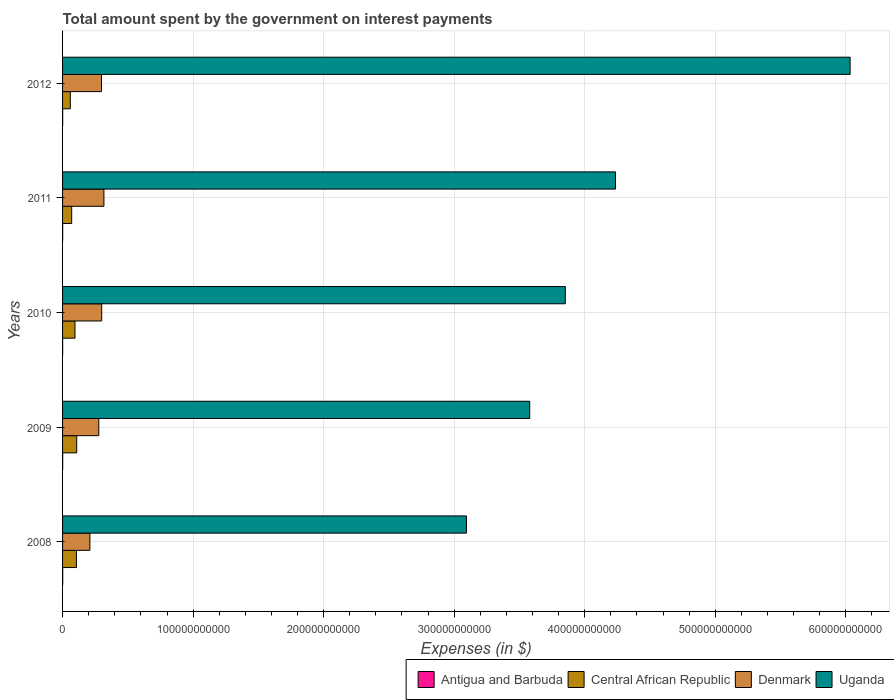How many groups of bars are there?
Your response must be concise. 5. Are the number of bars per tick equal to the number of legend labels?
Provide a short and direct response. Yes. Are the number of bars on each tick of the Y-axis equal?
Offer a very short reply. Yes. How many bars are there on the 1st tick from the top?
Ensure brevity in your answer.  4. How many bars are there on the 2nd tick from the bottom?
Your answer should be very brief. 4. In how many cases, is the number of bars for a given year not equal to the number of legend labels?
Keep it short and to the point. 0. What is the amount spent on interest payments by the government in Uganda in 2011?
Offer a terse response. 4.24e+11. Across all years, what is the maximum amount spent on interest payments by the government in Uganda?
Your response must be concise. 6.03e+11. Across all years, what is the minimum amount spent on interest payments by the government in Antigua and Barbuda?
Your answer should be very brief. 7.26e+07. In which year was the amount spent on interest payments by the government in Uganda maximum?
Offer a terse response. 2012. In which year was the amount spent on interest payments by the government in Central African Republic minimum?
Your answer should be compact. 2012. What is the total amount spent on interest payments by the government in Central African Republic in the graph?
Your response must be concise. 4.39e+1. What is the difference between the amount spent on interest payments by the government in Central African Republic in 2009 and that in 2011?
Provide a succinct answer. 3.85e+09. What is the difference between the amount spent on interest payments by the government in Denmark in 2010 and the amount spent on interest payments by the government in Antigua and Barbuda in 2008?
Provide a succinct answer. 2.99e+1. What is the average amount spent on interest payments by the government in Uganda per year?
Your answer should be very brief. 4.16e+11. In the year 2011, what is the difference between the amount spent on interest payments by the government in Central African Republic and amount spent on interest payments by the government in Uganda?
Provide a short and direct response. -4.17e+11. In how many years, is the amount spent on interest payments by the government in Uganda greater than 360000000000 $?
Provide a short and direct response. 3. What is the ratio of the amount spent on interest payments by the government in Denmark in 2010 to that in 2011?
Provide a succinct answer. 0.95. What is the difference between the highest and the second highest amount spent on interest payments by the government in Uganda?
Give a very brief answer. 1.80e+11. What is the difference between the highest and the lowest amount spent on interest payments by the government in Denmark?
Ensure brevity in your answer.  1.08e+1. In how many years, is the amount spent on interest payments by the government in Denmark greater than the average amount spent on interest payments by the government in Denmark taken over all years?
Give a very brief answer. 3. What does the 3rd bar from the top in 2009 represents?
Ensure brevity in your answer.  Central African Republic. What does the 2nd bar from the bottom in 2011 represents?
Offer a very short reply. Central African Republic. Is it the case that in every year, the sum of the amount spent on interest payments by the government in Central African Republic and amount spent on interest payments by the government in Denmark is greater than the amount spent on interest payments by the government in Antigua and Barbuda?
Make the answer very short. Yes. Are all the bars in the graph horizontal?
Your answer should be very brief. Yes. How many years are there in the graph?
Provide a succinct answer. 5. What is the difference between two consecutive major ticks on the X-axis?
Your answer should be very brief. 1.00e+11. Are the values on the major ticks of X-axis written in scientific E-notation?
Offer a terse response. No. Where does the legend appear in the graph?
Offer a terse response. Bottom right. What is the title of the graph?
Offer a very short reply. Total amount spent by the government on interest payments. Does "El Salvador" appear as one of the legend labels in the graph?
Provide a short and direct response. No. What is the label or title of the X-axis?
Provide a succinct answer. Expenses (in $). What is the label or title of the Y-axis?
Your answer should be compact. Years. What is the Expenses (in $) of Antigua and Barbuda in 2008?
Offer a very short reply. 1.03e+08. What is the Expenses (in $) in Central African Republic in 2008?
Provide a succinct answer. 1.06e+1. What is the Expenses (in $) of Denmark in 2008?
Offer a very short reply. 2.09e+1. What is the Expenses (in $) of Uganda in 2008?
Provide a short and direct response. 3.09e+11. What is the Expenses (in $) in Antigua and Barbuda in 2009?
Provide a succinct answer. 9.56e+07. What is the Expenses (in $) in Central African Republic in 2009?
Provide a short and direct response. 1.08e+1. What is the Expenses (in $) in Denmark in 2009?
Offer a terse response. 2.78e+1. What is the Expenses (in $) of Uganda in 2009?
Give a very brief answer. 3.58e+11. What is the Expenses (in $) in Antigua and Barbuda in 2010?
Provide a short and direct response. 7.26e+07. What is the Expenses (in $) of Central African Republic in 2010?
Your answer should be very brief. 9.51e+09. What is the Expenses (in $) of Denmark in 2010?
Offer a terse response. 3.00e+1. What is the Expenses (in $) in Uganda in 2010?
Offer a very short reply. 3.85e+11. What is the Expenses (in $) in Antigua and Barbuda in 2011?
Your answer should be compact. 7.73e+07. What is the Expenses (in $) in Central African Republic in 2011?
Provide a short and direct response. 6.98e+09. What is the Expenses (in $) of Denmark in 2011?
Ensure brevity in your answer.  3.17e+1. What is the Expenses (in $) in Uganda in 2011?
Offer a very short reply. 4.24e+11. What is the Expenses (in $) in Antigua and Barbuda in 2012?
Your answer should be very brief. 8.00e+07. What is the Expenses (in $) in Central African Republic in 2012?
Offer a terse response. 5.92e+09. What is the Expenses (in $) in Denmark in 2012?
Provide a short and direct response. 2.98e+1. What is the Expenses (in $) of Uganda in 2012?
Offer a very short reply. 6.03e+11. Across all years, what is the maximum Expenses (in $) of Antigua and Barbuda?
Ensure brevity in your answer.  1.03e+08. Across all years, what is the maximum Expenses (in $) in Central African Republic?
Your response must be concise. 1.08e+1. Across all years, what is the maximum Expenses (in $) of Denmark?
Your answer should be very brief. 3.17e+1. Across all years, what is the maximum Expenses (in $) of Uganda?
Ensure brevity in your answer.  6.03e+11. Across all years, what is the minimum Expenses (in $) in Antigua and Barbuda?
Offer a very short reply. 7.26e+07. Across all years, what is the minimum Expenses (in $) of Central African Republic?
Your answer should be very brief. 5.92e+09. Across all years, what is the minimum Expenses (in $) of Denmark?
Provide a short and direct response. 2.09e+1. Across all years, what is the minimum Expenses (in $) in Uganda?
Ensure brevity in your answer.  3.09e+11. What is the total Expenses (in $) in Antigua and Barbuda in the graph?
Give a very brief answer. 4.28e+08. What is the total Expenses (in $) of Central African Republic in the graph?
Offer a terse response. 4.39e+1. What is the total Expenses (in $) in Denmark in the graph?
Give a very brief answer. 1.40e+11. What is the total Expenses (in $) in Uganda in the graph?
Make the answer very short. 2.08e+12. What is the difference between the Expenses (in $) of Central African Republic in 2008 and that in 2009?
Offer a very short reply. -2.10e+08. What is the difference between the Expenses (in $) in Denmark in 2008 and that in 2009?
Your answer should be very brief. -6.84e+09. What is the difference between the Expenses (in $) of Uganda in 2008 and that in 2009?
Offer a very short reply. -4.85e+1. What is the difference between the Expenses (in $) of Antigua and Barbuda in 2008 and that in 2010?
Your answer should be compact. 3.00e+07. What is the difference between the Expenses (in $) in Central African Republic in 2008 and that in 2010?
Offer a terse response. 1.11e+09. What is the difference between the Expenses (in $) of Denmark in 2008 and that in 2010?
Your answer should be very brief. -9.05e+09. What is the difference between the Expenses (in $) of Uganda in 2008 and that in 2010?
Offer a terse response. -7.57e+1. What is the difference between the Expenses (in $) of Antigua and Barbuda in 2008 and that in 2011?
Keep it short and to the point. 2.53e+07. What is the difference between the Expenses (in $) of Central African Republic in 2008 and that in 2011?
Keep it short and to the point. 3.64e+09. What is the difference between the Expenses (in $) in Denmark in 2008 and that in 2011?
Ensure brevity in your answer.  -1.08e+1. What is the difference between the Expenses (in $) of Uganda in 2008 and that in 2011?
Give a very brief answer. -1.14e+11. What is the difference between the Expenses (in $) of Antigua and Barbuda in 2008 and that in 2012?
Your response must be concise. 2.26e+07. What is the difference between the Expenses (in $) in Central African Republic in 2008 and that in 2012?
Make the answer very short. 4.70e+09. What is the difference between the Expenses (in $) of Denmark in 2008 and that in 2012?
Offer a very short reply. -8.90e+09. What is the difference between the Expenses (in $) of Uganda in 2008 and that in 2012?
Make the answer very short. -2.94e+11. What is the difference between the Expenses (in $) of Antigua and Barbuda in 2009 and that in 2010?
Your answer should be compact. 2.30e+07. What is the difference between the Expenses (in $) of Central African Republic in 2009 and that in 2010?
Provide a succinct answer. 1.32e+09. What is the difference between the Expenses (in $) in Denmark in 2009 and that in 2010?
Make the answer very short. -2.21e+09. What is the difference between the Expenses (in $) in Uganda in 2009 and that in 2010?
Offer a very short reply. -2.73e+1. What is the difference between the Expenses (in $) in Antigua and Barbuda in 2009 and that in 2011?
Provide a short and direct response. 1.83e+07. What is the difference between the Expenses (in $) of Central African Republic in 2009 and that in 2011?
Your response must be concise. 3.85e+09. What is the difference between the Expenses (in $) of Denmark in 2009 and that in 2011?
Provide a short and direct response. -3.92e+09. What is the difference between the Expenses (in $) in Uganda in 2009 and that in 2011?
Make the answer very short. -6.57e+1. What is the difference between the Expenses (in $) of Antigua and Barbuda in 2009 and that in 2012?
Your answer should be very brief. 1.56e+07. What is the difference between the Expenses (in $) of Central African Republic in 2009 and that in 2012?
Ensure brevity in your answer.  4.91e+09. What is the difference between the Expenses (in $) of Denmark in 2009 and that in 2012?
Ensure brevity in your answer.  -2.06e+09. What is the difference between the Expenses (in $) in Uganda in 2009 and that in 2012?
Provide a succinct answer. -2.45e+11. What is the difference between the Expenses (in $) in Antigua and Barbuda in 2010 and that in 2011?
Your answer should be very brief. -4.70e+06. What is the difference between the Expenses (in $) in Central African Republic in 2010 and that in 2011?
Your response must be concise. 2.53e+09. What is the difference between the Expenses (in $) in Denmark in 2010 and that in 2011?
Provide a succinct answer. -1.71e+09. What is the difference between the Expenses (in $) in Uganda in 2010 and that in 2011?
Your answer should be compact. -3.84e+1. What is the difference between the Expenses (in $) in Antigua and Barbuda in 2010 and that in 2012?
Provide a short and direct response. -7.40e+06. What is the difference between the Expenses (in $) of Central African Republic in 2010 and that in 2012?
Your answer should be compact. 3.59e+09. What is the difference between the Expenses (in $) of Denmark in 2010 and that in 2012?
Give a very brief answer. 1.47e+08. What is the difference between the Expenses (in $) of Uganda in 2010 and that in 2012?
Your answer should be compact. -2.18e+11. What is the difference between the Expenses (in $) in Antigua and Barbuda in 2011 and that in 2012?
Ensure brevity in your answer.  -2.70e+06. What is the difference between the Expenses (in $) of Central African Republic in 2011 and that in 2012?
Your answer should be very brief. 1.06e+09. What is the difference between the Expenses (in $) in Denmark in 2011 and that in 2012?
Ensure brevity in your answer.  1.86e+09. What is the difference between the Expenses (in $) in Uganda in 2011 and that in 2012?
Offer a terse response. -1.80e+11. What is the difference between the Expenses (in $) in Antigua and Barbuda in 2008 and the Expenses (in $) in Central African Republic in 2009?
Keep it short and to the point. -1.07e+1. What is the difference between the Expenses (in $) in Antigua and Barbuda in 2008 and the Expenses (in $) in Denmark in 2009?
Your answer should be very brief. -2.77e+1. What is the difference between the Expenses (in $) in Antigua and Barbuda in 2008 and the Expenses (in $) in Uganda in 2009?
Your answer should be very brief. -3.58e+11. What is the difference between the Expenses (in $) in Central African Republic in 2008 and the Expenses (in $) in Denmark in 2009?
Provide a succinct answer. -1.71e+1. What is the difference between the Expenses (in $) of Central African Republic in 2008 and the Expenses (in $) of Uganda in 2009?
Your response must be concise. -3.47e+11. What is the difference between the Expenses (in $) of Denmark in 2008 and the Expenses (in $) of Uganda in 2009?
Provide a succinct answer. -3.37e+11. What is the difference between the Expenses (in $) of Antigua and Barbuda in 2008 and the Expenses (in $) of Central African Republic in 2010?
Provide a succinct answer. -9.41e+09. What is the difference between the Expenses (in $) of Antigua and Barbuda in 2008 and the Expenses (in $) of Denmark in 2010?
Give a very brief answer. -2.99e+1. What is the difference between the Expenses (in $) in Antigua and Barbuda in 2008 and the Expenses (in $) in Uganda in 2010?
Provide a short and direct response. -3.85e+11. What is the difference between the Expenses (in $) of Central African Republic in 2008 and the Expenses (in $) of Denmark in 2010?
Provide a succinct answer. -1.93e+1. What is the difference between the Expenses (in $) in Central African Republic in 2008 and the Expenses (in $) in Uganda in 2010?
Your response must be concise. -3.75e+11. What is the difference between the Expenses (in $) in Denmark in 2008 and the Expenses (in $) in Uganda in 2010?
Make the answer very short. -3.64e+11. What is the difference between the Expenses (in $) in Antigua and Barbuda in 2008 and the Expenses (in $) in Central African Republic in 2011?
Offer a terse response. -6.88e+09. What is the difference between the Expenses (in $) of Antigua and Barbuda in 2008 and the Expenses (in $) of Denmark in 2011?
Your response must be concise. -3.16e+1. What is the difference between the Expenses (in $) in Antigua and Barbuda in 2008 and the Expenses (in $) in Uganda in 2011?
Your answer should be compact. -4.23e+11. What is the difference between the Expenses (in $) in Central African Republic in 2008 and the Expenses (in $) in Denmark in 2011?
Keep it short and to the point. -2.11e+1. What is the difference between the Expenses (in $) of Central African Republic in 2008 and the Expenses (in $) of Uganda in 2011?
Make the answer very short. -4.13e+11. What is the difference between the Expenses (in $) of Denmark in 2008 and the Expenses (in $) of Uganda in 2011?
Provide a short and direct response. -4.03e+11. What is the difference between the Expenses (in $) in Antigua and Barbuda in 2008 and the Expenses (in $) in Central African Republic in 2012?
Keep it short and to the point. -5.82e+09. What is the difference between the Expenses (in $) in Antigua and Barbuda in 2008 and the Expenses (in $) in Denmark in 2012?
Your answer should be very brief. -2.97e+1. What is the difference between the Expenses (in $) of Antigua and Barbuda in 2008 and the Expenses (in $) of Uganda in 2012?
Provide a short and direct response. -6.03e+11. What is the difference between the Expenses (in $) of Central African Republic in 2008 and the Expenses (in $) of Denmark in 2012?
Give a very brief answer. -1.92e+1. What is the difference between the Expenses (in $) in Central African Republic in 2008 and the Expenses (in $) in Uganda in 2012?
Your answer should be compact. -5.93e+11. What is the difference between the Expenses (in $) of Denmark in 2008 and the Expenses (in $) of Uganda in 2012?
Offer a terse response. -5.82e+11. What is the difference between the Expenses (in $) of Antigua and Barbuda in 2009 and the Expenses (in $) of Central African Republic in 2010?
Give a very brief answer. -9.42e+09. What is the difference between the Expenses (in $) of Antigua and Barbuda in 2009 and the Expenses (in $) of Denmark in 2010?
Keep it short and to the point. -2.99e+1. What is the difference between the Expenses (in $) of Antigua and Barbuda in 2009 and the Expenses (in $) of Uganda in 2010?
Your response must be concise. -3.85e+11. What is the difference between the Expenses (in $) in Central African Republic in 2009 and the Expenses (in $) in Denmark in 2010?
Keep it short and to the point. -1.91e+1. What is the difference between the Expenses (in $) of Central African Republic in 2009 and the Expenses (in $) of Uganda in 2010?
Offer a terse response. -3.74e+11. What is the difference between the Expenses (in $) in Denmark in 2009 and the Expenses (in $) in Uganda in 2010?
Give a very brief answer. -3.57e+11. What is the difference between the Expenses (in $) in Antigua and Barbuda in 2009 and the Expenses (in $) in Central African Republic in 2011?
Give a very brief answer. -6.89e+09. What is the difference between the Expenses (in $) in Antigua and Barbuda in 2009 and the Expenses (in $) in Denmark in 2011?
Make the answer very short. -3.16e+1. What is the difference between the Expenses (in $) in Antigua and Barbuda in 2009 and the Expenses (in $) in Uganda in 2011?
Make the answer very short. -4.23e+11. What is the difference between the Expenses (in $) in Central African Republic in 2009 and the Expenses (in $) in Denmark in 2011?
Ensure brevity in your answer.  -2.08e+1. What is the difference between the Expenses (in $) of Central African Republic in 2009 and the Expenses (in $) of Uganda in 2011?
Give a very brief answer. -4.13e+11. What is the difference between the Expenses (in $) of Denmark in 2009 and the Expenses (in $) of Uganda in 2011?
Make the answer very short. -3.96e+11. What is the difference between the Expenses (in $) in Antigua and Barbuda in 2009 and the Expenses (in $) in Central African Republic in 2012?
Provide a short and direct response. -5.83e+09. What is the difference between the Expenses (in $) in Antigua and Barbuda in 2009 and the Expenses (in $) in Denmark in 2012?
Offer a terse response. -2.97e+1. What is the difference between the Expenses (in $) in Antigua and Barbuda in 2009 and the Expenses (in $) in Uganda in 2012?
Provide a succinct answer. -6.03e+11. What is the difference between the Expenses (in $) of Central African Republic in 2009 and the Expenses (in $) of Denmark in 2012?
Your answer should be very brief. -1.90e+1. What is the difference between the Expenses (in $) of Central African Republic in 2009 and the Expenses (in $) of Uganda in 2012?
Keep it short and to the point. -5.92e+11. What is the difference between the Expenses (in $) of Denmark in 2009 and the Expenses (in $) of Uganda in 2012?
Offer a very short reply. -5.76e+11. What is the difference between the Expenses (in $) of Antigua and Barbuda in 2010 and the Expenses (in $) of Central African Republic in 2011?
Keep it short and to the point. -6.91e+09. What is the difference between the Expenses (in $) in Antigua and Barbuda in 2010 and the Expenses (in $) in Denmark in 2011?
Make the answer very short. -3.16e+1. What is the difference between the Expenses (in $) in Antigua and Barbuda in 2010 and the Expenses (in $) in Uganda in 2011?
Your answer should be compact. -4.23e+11. What is the difference between the Expenses (in $) in Central African Republic in 2010 and the Expenses (in $) in Denmark in 2011?
Make the answer very short. -2.22e+1. What is the difference between the Expenses (in $) in Central African Republic in 2010 and the Expenses (in $) in Uganda in 2011?
Keep it short and to the point. -4.14e+11. What is the difference between the Expenses (in $) of Denmark in 2010 and the Expenses (in $) of Uganda in 2011?
Give a very brief answer. -3.94e+11. What is the difference between the Expenses (in $) in Antigua and Barbuda in 2010 and the Expenses (in $) in Central African Republic in 2012?
Provide a succinct answer. -5.85e+09. What is the difference between the Expenses (in $) of Antigua and Barbuda in 2010 and the Expenses (in $) of Denmark in 2012?
Offer a terse response. -2.97e+1. What is the difference between the Expenses (in $) in Antigua and Barbuda in 2010 and the Expenses (in $) in Uganda in 2012?
Keep it short and to the point. -6.03e+11. What is the difference between the Expenses (in $) of Central African Republic in 2010 and the Expenses (in $) of Denmark in 2012?
Ensure brevity in your answer.  -2.03e+1. What is the difference between the Expenses (in $) in Central African Republic in 2010 and the Expenses (in $) in Uganda in 2012?
Keep it short and to the point. -5.94e+11. What is the difference between the Expenses (in $) of Denmark in 2010 and the Expenses (in $) of Uganda in 2012?
Your response must be concise. -5.73e+11. What is the difference between the Expenses (in $) in Antigua and Barbuda in 2011 and the Expenses (in $) in Central African Republic in 2012?
Offer a very short reply. -5.85e+09. What is the difference between the Expenses (in $) of Antigua and Barbuda in 2011 and the Expenses (in $) of Denmark in 2012?
Your answer should be compact. -2.97e+1. What is the difference between the Expenses (in $) of Antigua and Barbuda in 2011 and the Expenses (in $) of Uganda in 2012?
Offer a very short reply. -6.03e+11. What is the difference between the Expenses (in $) in Central African Republic in 2011 and the Expenses (in $) in Denmark in 2012?
Give a very brief answer. -2.28e+1. What is the difference between the Expenses (in $) of Central African Republic in 2011 and the Expenses (in $) of Uganda in 2012?
Provide a succinct answer. -5.96e+11. What is the difference between the Expenses (in $) in Denmark in 2011 and the Expenses (in $) in Uganda in 2012?
Ensure brevity in your answer.  -5.72e+11. What is the average Expenses (in $) in Antigua and Barbuda per year?
Offer a terse response. 8.56e+07. What is the average Expenses (in $) in Central African Republic per year?
Offer a terse response. 8.77e+09. What is the average Expenses (in $) of Denmark per year?
Make the answer very short. 2.80e+1. What is the average Expenses (in $) of Uganda per year?
Ensure brevity in your answer.  4.16e+11. In the year 2008, what is the difference between the Expenses (in $) in Antigua and Barbuda and Expenses (in $) in Central African Republic?
Offer a very short reply. -1.05e+1. In the year 2008, what is the difference between the Expenses (in $) in Antigua and Barbuda and Expenses (in $) in Denmark?
Provide a succinct answer. -2.08e+1. In the year 2008, what is the difference between the Expenses (in $) of Antigua and Barbuda and Expenses (in $) of Uganda?
Offer a very short reply. -3.09e+11. In the year 2008, what is the difference between the Expenses (in $) in Central African Republic and Expenses (in $) in Denmark?
Keep it short and to the point. -1.03e+1. In the year 2008, what is the difference between the Expenses (in $) in Central African Republic and Expenses (in $) in Uganda?
Keep it short and to the point. -2.99e+11. In the year 2008, what is the difference between the Expenses (in $) of Denmark and Expenses (in $) of Uganda?
Offer a very short reply. -2.88e+11. In the year 2009, what is the difference between the Expenses (in $) in Antigua and Barbuda and Expenses (in $) in Central African Republic?
Provide a short and direct response. -1.07e+1. In the year 2009, what is the difference between the Expenses (in $) of Antigua and Barbuda and Expenses (in $) of Denmark?
Your answer should be very brief. -2.77e+1. In the year 2009, what is the difference between the Expenses (in $) of Antigua and Barbuda and Expenses (in $) of Uganda?
Make the answer very short. -3.58e+11. In the year 2009, what is the difference between the Expenses (in $) in Central African Republic and Expenses (in $) in Denmark?
Offer a very short reply. -1.69e+1. In the year 2009, what is the difference between the Expenses (in $) in Central African Republic and Expenses (in $) in Uganda?
Your response must be concise. -3.47e+11. In the year 2009, what is the difference between the Expenses (in $) of Denmark and Expenses (in $) of Uganda?
Make the answer very short. -3.30e+11. In the year 2010, what is the difference between the Expenses (in $) of Antigua and Barbuda and Expenses (in $) of Central African Republic?
Make the answer very short. -9.44e+09. In the year 2010, what is the difference between the Expenses (in $) in Antigua and Barbuda and Expenses (in $) in Denmark?
Provide a short and direct response. -2.99e+1. In the year 2010, what is the difference between the Expenses (in $) of Antigua and Barbuda and Expenses (in $) of Uganda?
Keep it short and to the point. -3.85e+11. In the year 2010, what is the difference between the Expenses (in $) of Central African Republic and Expenses (in $) of Denmark?
Your answer should be compact. -2.05e+1. In the year 2010, what is the difference between the Expenses (in $) in Central African Republic and Expenses (in $) in Uganda?
Your answer should be very brief. -3.76e+11. In the year 2010, what is the difference between the Expenses (in $) of Denmark and Expenses (in $) of Uganda?
Offer a very short reply. -3.55e+11. In the year 2011, what is the difference between the Expenses (in $) of Antigua and Barbuda and Expenses (in $) of Central African Republic?
Ensure brevity in your answer.  -6.91e+09. In the year 2011, what is the difference between the Expenses (in $) of Antigua and Barbuda and Expenses (in $) of Denmark?
Make the answer very short. -3.16e+1. In the year 2011, what is the difference between the Expenses (in $) in Antigua and Barbuda and Expenses (in $) in Uganda?
Provide a short and direct response. -4.23e+11. In the year 2011, what is the difference between the Expenses (in $) in Central African Republic and Expenses (in $) in Denmark?
Give a very brief answer. -2.47e+1. In the year 2011, what is the difference between the Expenses (in $) of Central African Republic and Expenses (in $) of Uganda?
Give a very brief answer. -4.17e+11. In the year 2011, what is the difference between the Expenses (in $) in Denmark and Expenses (in $) in Uganda?
Your answer should be very brief. -3.92e+11. In the year 2012, what is the difference between the Expenses (in $) in Antigua and Barbuda and Expenses (in $) in Central African Republic?
Ensure brevity in your answer.  -5.84e+09. In the year 2012, what is the difference between the Expenses (in $) of Antigua and Barbuda and Expenses (in $) of Denmark?
Your answer should be compact. -2.97e+1. In the year 2012, what is the difference between the Expenses (in $) in Antigua and Barbuda and Expenses (in $) in Uganda?
Offer a terse response. -6.03e+11. In the year 2012, what is the difference between the Expenses (in $) of Central African Republic and Expenses (in $) of Denmark?
Provide a succinct answer. -2.39e+1. In the year 2012, what is the difference between the Expenses (in $) of Central African Republic and Expenses (in $) of Uganda?
Offer a very short reply. -5.97e+11. In the year 2012, what is the difference between the Expenses (in $) in Denmark and Expenses (in $) in Uganda?
Make the answer very short. -5.73e+11. What is the ratio of the Expenses (in $) in Antigua and Barbuda in 2008 to that in 2009?
Your answer should be very brief. 1.07. What is the ratio of the Expenses (in $) in Central African Republic in 2008 to that in 2009?
Provide a succinct answer. 0.98. What is the ratio of the Expenses (in $) of Denmark in 2008 to that in 2009?
Offer a very short reply. 0.75. What is the ratio of the Expenses (in $) in Uganda in 2008 to that in 2009?
Offer a terse response. 0.86. What is the ratio of the Expenses (in $) in Antigua and Barbuda in 2008 to that in 2010?
Your answer should be very brief. 1.41. What is the ratio of the Expenses (in $) in Central African Republic in 2008 to that in 2010?
Your answer should be very brief. 1.12. What is the ratio of the Expenses (in $) of Denmark in 2008 to that in 2010?
Offer a very short reply. 0.7. What is the ratio of the Expenses (in $) of Uganda in 2008 to that in 2010?
Provide a succinct answer. 0.8. What is the ratio of the Expenses (in $) in Antigua and Barbuda in 2008 to that in 2011?
Ensure brevity in your answer.  1.33. What is the ratio of the Expenses (in $) of Central African Republic in 2008 to that in 2011?
Your answer should be compact. 1.52. What is the ratio of the Expenses (in $) in Denmark in 2008 to that in 2011?
Your answer should be compact. 0.66. What is the ratio of the Expenses (in $) in Uganda in 2008 to that in 2011?
Give a very brief answer. 0.73. What is the ratio of the Expenses (in $) of Antigua and Barbuda in 2008 to that in 2012?
Offer a very short reply. 1.28. What is the ratio of the Expenses (in $) in Central African Republic in 2008 to that in 2012?
Provide a succinct answer. 1.79. What is the ratio of the Expenses (in $) of Denmark in 2008 to that in 2012?
Provide a succinct answer. 0.7. What is the ratio of the Expenses (in $) of Uganda in 2008 to that in 2012?
Your response must be concise. 0.51. What is the ratio of the Expenses (in $) in Antigua and Barbuda in 2009 to that in 2010?
Provide a succinct answer. 1.32. What is the ratio of the Expenses (in $) of Central African Republic in 2009 to that in 2010?
Provide a short and direct response. 1.14. What is the ratio of the Expenses (in $) of Denmark in 2009 to that in 2010?
Provide a short and direct response. 0.93. What is the ratio of the Expenses (in $) in Uganda in 2009 to that in 2010?
Your answer should be compact. 0.93. What is the ratio of the Expenses (in $) of Antigua and Barbuda in 2009 to that in 2011?
Your response must be concise. 1.24. What is the ratio of the Expenses (in $) in Central African Republic in 2009 to that in 2011?
Ensure brevity in your answer.  1.55. What is the ratio of the Expenses (in $) of Denmark in 2009 to that in 2011?
Your answer should be compact. 0.88. What is the ratio of the Expenses (in $) in Uganda in 2009 to that in 2011?
Your answer should be very brief. 0.84. What is the ratio of the Expenses (in $) of Antigua and Barbuda in 2009 to that in 2012?
Your response must be concise. 1.2. What is the ratio of the Expenses (in $) of Central African Republic in 2009 to that in 2012?
Offer a very short reply. 1.83. What is the ratio of the Expenses (in $) of Denmark in 2009 to that in 2012?
Give a very brief answer. 0.93. What is the ratio of the Expenses (in $) in Uganda in 2009 to that in 2012?
Give a very brief answer. 0.59. What is the ratio of the Expenses (in $) in Antigua and Barbuda in 2010 to that in 2011?
Offer a very short reply. 0.94. What is the ratio of the Expenses (in $) of Central African Republic in 2010 to that in 2011?
Keep it short and to the point. 1.36. What is the ratio of the Expenses (in $) in Denmark in 2010 to that in 2011?
Make the answer very short. 0.95. What is the ratio of the Expenses (in $) of Uganda in 2010 to that in 2011?
Your answer should be compact. 0.91. What is the ratio of the Expenses (in $) in Antigua and Barbuda in 2010 to that in 2012?
Provide a short and direct response. 0.91. What is the ratio of the Expenses (in $) of Central African Republic in 2010 to that in 2012?
Make the answer very short. 1.61. What is the ratio of the Expenses (in $) of Uganda in 2010 to that in 2012?
Provide a succinct answer. 0.64. What is the ratio of the Expenses (in $) of Antigua and Barbuda in 2011 to that in 2012?
Make the answer very short. 0.97. What is the ratio of the Expenses (in $) of Central African Republic in 2011 to that in 2012?
Give a very brief answer. 1.18. What is the ratio of the Expenses (in $) of Denmark in 2011 to that in 2012?
Provide a succinct answer. 1.06. What is the ratio of the Expenses (in $) in Uganda in 2011 to that in 2012?
Give a very brief answer. 0.7. What is the difference between the highest and the second highest Expenses (in $) of Central African Republic?
Offer a very short reply. 2.10e+08. What is the difference between the highest and the second highest Expenses (in $) of Denmark?
Give a very brief answer. 1.71e+09. What is the difference between the highest and the second highest Expenses (in $) in Uganda?
Your answer should be compact. 1.80e+11. What is the difference between the highest and the lowest Expenses (in $) of Antigua and Barbuda?
Ensure brevity in your answer.  3.00e+07. What is the difference between the highest and the lowest Expenses (in $) in Central African Republic?
Your answer should be very brief. 4.91e+09. What is the difference between the highest and the lowest Expenses (in $) of Denmark?
Keep it short and to the point. 1.08e+1. What is the difference between the highest and the lowest Expenses (in $) of Uganda?
Your answer should be very brief. 2.94e+11. 